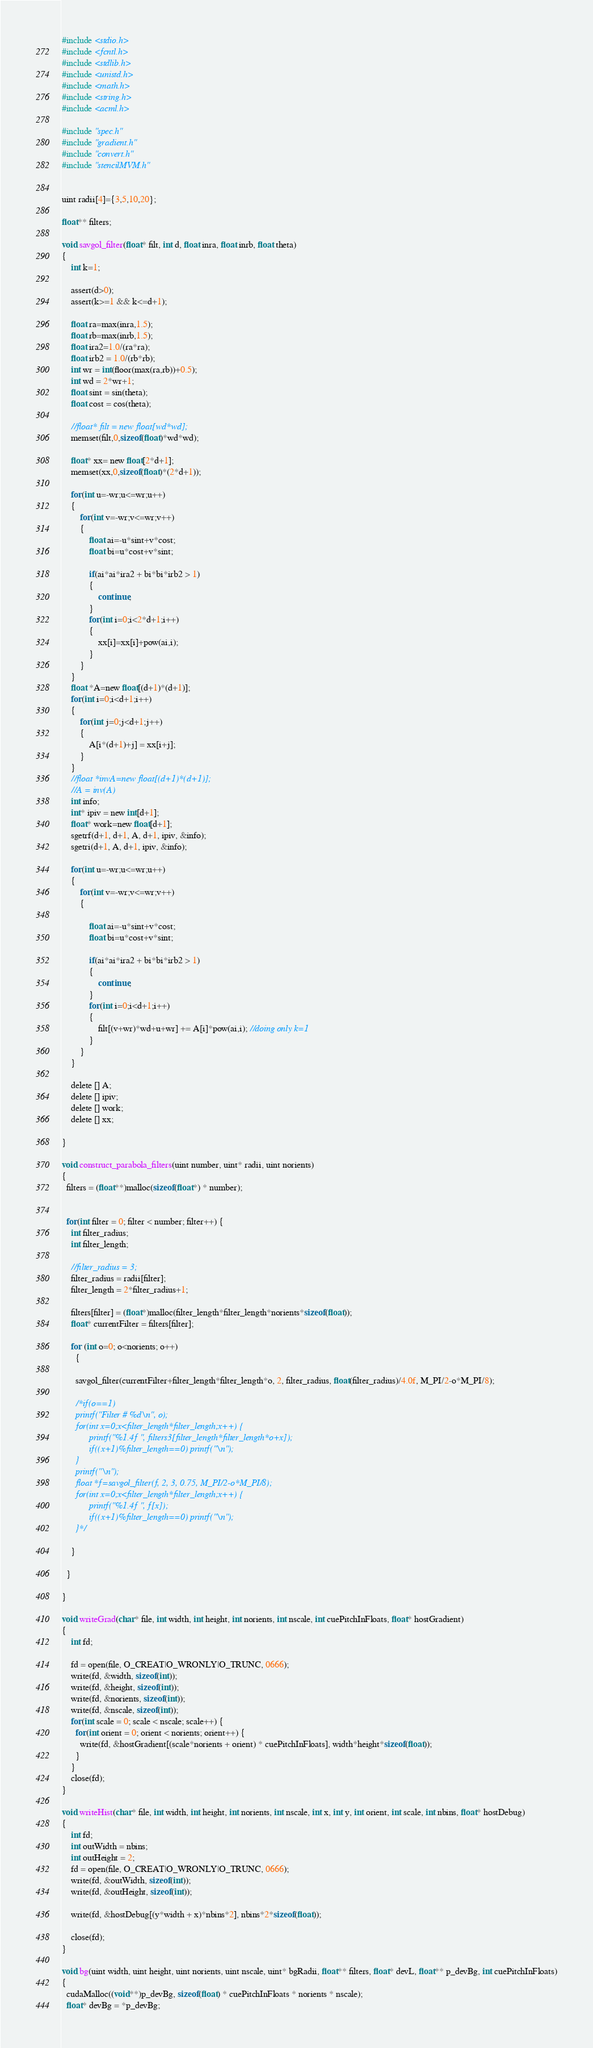<code> <loc_0><loc_0><loc_500><loc_500><_Cuda_>#include <stdio.h>
#include <fcntl.h>
#include <stdlib.h>
#include <unistd.h>
#include <math.h>
#include <string.h>
#include <acml.h>

#include "spec.h"
#include "gradient.h"
#include "convert.h"
#include "stencilMVM.h"


uint radii[4]={3,5,10,20};

float** filters;

void savgol_filter(float* filt, int d, float inra, float inrb, float theta)
{
    int k=1;

    assert(d>0);
    assert(k>=1 && k<=d+1);

    float ra=max(inra,1.5);
    float rb=max(inrb,1.5);
    float ira2=1.0/(ra*ra);
    float irb2 = 1.0/(rb*rb);
    int wr = int(floor(max(ra,rb))+0.5);
    int wd = 2*wr+1;
    float sint = sin(theta);
    float cost = cos(theta);

    //float* filt = new float[wd*wd];
    memset(filt,0,sizeof(float)*wd*wd);

    float* xx= new float[2*d+1];
    memset(xx,0,sizeof(float)*(2*d+1));

    for(int u=-wr;u<=wr;u++)
    {
        for(int v=-wr;v<=wr;v++)
        {
            float ai=-u*sint+v*cost;
            float bi=u*cost+v*sint;

            if(ai*ai*ira2 + bi*bi*irb2 > 1)
            {
                continue;
            }
            for(int i=0;i<2*d+1;i++)
            {
                xx[i]=xx[i]+pow(ai,i);
            }
        }
    }
    float *A=new float[(d+1)*(d+1)];
    for(int i=0;i<d+1;i++)
    {
        for(int j=0;j<d+1;j++)
        {
            A[i*(d+1)+j] = xx[i+j];
        }
    }
    //float *invA=new float[(d+1)*(d+1)];
    //A = inv(A)
    int info;
    int* ipiv = new int[d+1];
    float* work=new float[d+1];
    sgetrf(d+1, d+1, A, d+1, ipiv, &info);
    sgetri(d+1, A, d+1, ipiv, &info);

    for(int u=-wr;u<=wr;u++)
    {
        for(int v=-wr;v<=wr;v++)
        {
            
            float ai=-u*sint+v*cost;
            float bi=u*cost+v*sint;

            if(ai*ai*ira2 + bi*bi*irb2 > 1)
            {
                continue;
            }
            for(int i=0;i<d+1;i++)
            {
                filt[(v+wr)*wd+u+wr] += A[i]*pow(ai,i); //doing only k=1
            }
        }
    }

    delete [] A;
    delete [] ipiv;
    delete [] work;
    delete [] xx;

}

void construct_parabola_filters(uint number, uint* radii, uint norients)
{
  filters = (float**)malloc(sizeof(float*) * number);


  for(int filter = 0; filter < number; filter++) {
    int filter_radius;
    int filter_length;

    //filter_radius = 3;
    filter_radius = radii[filter];
    filter_length = 2*filter_radius+1;
  
    filters[filter] = (float*)malloc(filter_length*filter_length*norients*sizeof(float));
    float* currentFilter = filters[filter];
    
    for (int o=0; o<norients; o++)
      {
      
      savgol_filter(currentFilter+filter_length*filter_length*o, 2, filter_radius, float(filter_radius)/4.0f, M_PI/2-o*M_PI/8);

      /*if(o==1) 
      printf("Filter # %d\n", o);
      for(int x=0;x<filter_length*filter_length;x++) {
            printf("%1.4f ", filters3[filter_length*filter_length*o+x]);
            if((x+1)%filter_length==0) printf("\n");
      }
      printf("\n");
      float *f=savgol_filter(f, 2, 3, 0.75, M_PI/2-o*M_PI/8);
      for(int x=0;x<filter_length*filter_length;x++) {
            printf("%1.4f ", f[x]);
            if((x+1)%filter_length==0) printf("\n");
      }*/

    }

  }

}

void writeGrad(char* file, int width, int height, int norients, int nscale, int cuePitchInFloats, float* hostGradient)
{
    int fd;

    fd = open(file, O_CREAT|O_WRONLY|O_TRUNC, 0666);
    write(fd, &width, sizeof(int));
    write(fd, &height, sizeof(int));
    write(fd, &norients, sizeof(int));
    write(fd, &nscale, sizeof(int));
    for(int scale = 0; scale < nscale; scale++) {
      for(int orient = 0; orient < norients; orient++) {
        write(fd, &hostGradient[(scale*norients + orient) * cuePitchInFloats], width*height*sizeof(float));
      }
    }
    close(fd);
}

void writeHist(char* file, int width, int height, int norients, int nscale, int x, int y, int orient, int scale, int nbins, float* hostDebug)
{
    int fd;
    int outWidth = nbins;
    int outHeight = 2;
    fd = open(file, O_CREAT|O_WRONLY|O_TRUNC, 0666);
    write(fd, &outWidth, sizeof(int));
    write(fd, &outHeight, sizeof(int));

    write(fd, &hostDebug[(y*width + x)*nbins*2], nbins*2*sizeof(float));

    close(fd);
}

void bg(uint width, uint height, uint norients, uint nscale, uint* bgRadii, float** filters, float* devL, float** p_devBg, int cuePitchInFloats)
{
  cudaMalloc((void**)p_devBg, sizeof(float) * cuePitchInFloats * norients * nscale);
  float* devBg = *p_devBg;

</code> 